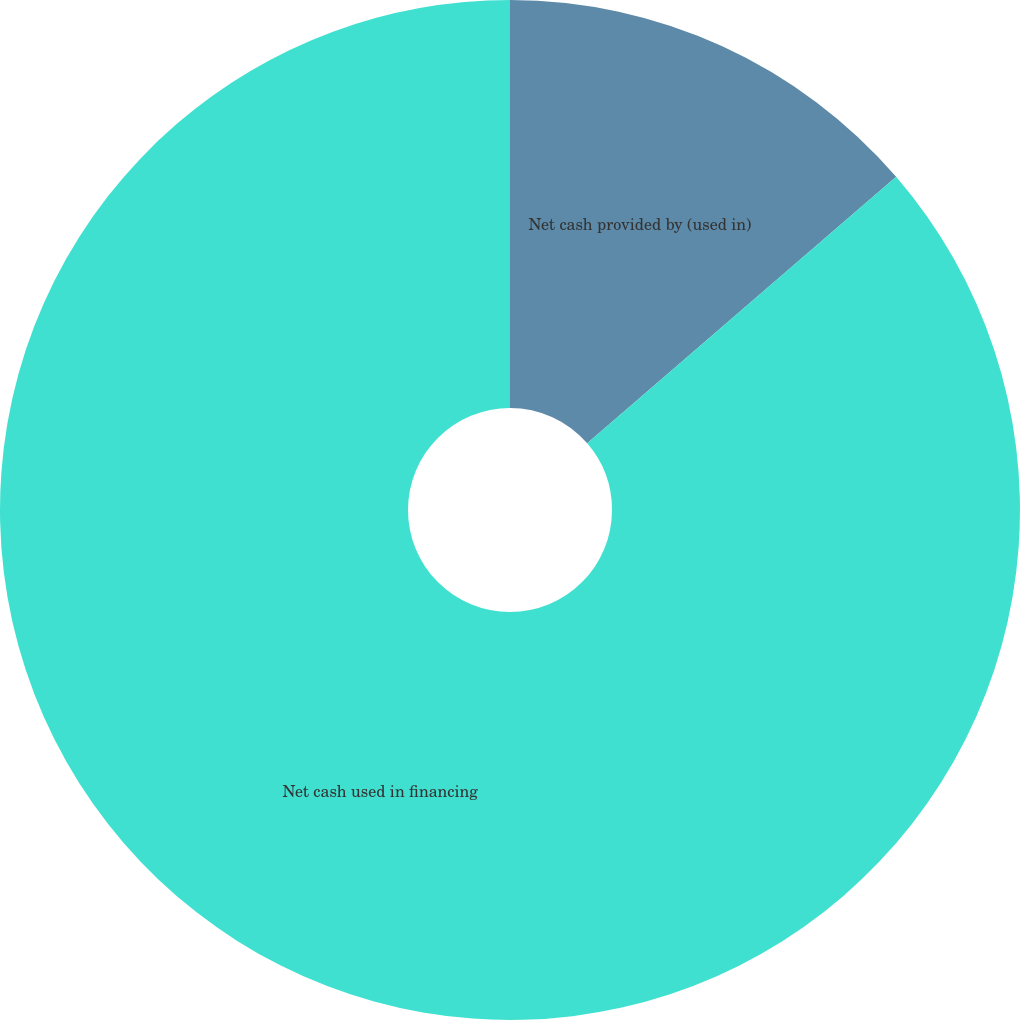<chart> <loc_0><loc_0><loc_500><loc_500><pie_chart><fcel>Net cash provided by (used in)<fcel>Net cash used in financing<nl><fcel>13.67%<fcel>86.33%<nl></chart> 